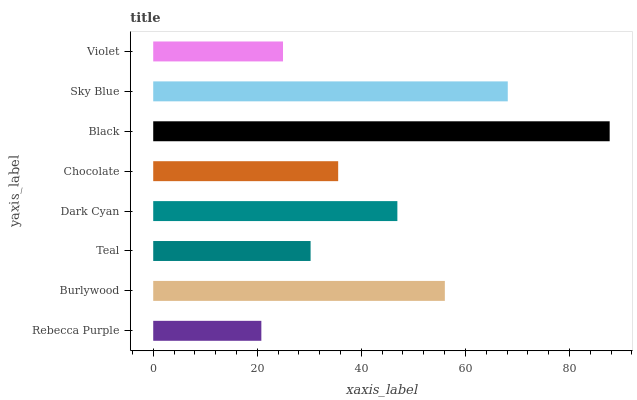Is Rebecca Purple the minimum?
Answer yes or no. Yes. Is Black the maximum?
Answer yes or no. Yes. Is Burlywood the minimum?
Answer yes or no. No. Is Burlywood the maximum?
Answer yes or no. No. Is Burlywood greater than Rebecca Purple?
Answer yes or no. Yes. Is Rebecca Purple less than Burlywood?
Answer yes or no. Yes. Is Rebecca Purple greater than Burlywood?
Answer yes or no. No. Is Burlywood less than Rebecca Purple?
Answer yes or no. No. Is Dark Cyan the high median?
Answer yes or no. Yes. Is Chocolate the low median?
Answer yes or no. Yes. Is Chocolate the high median?
Answer yes or no. No. Is Dark Cyan the low median?
Answer yes or no. No. 